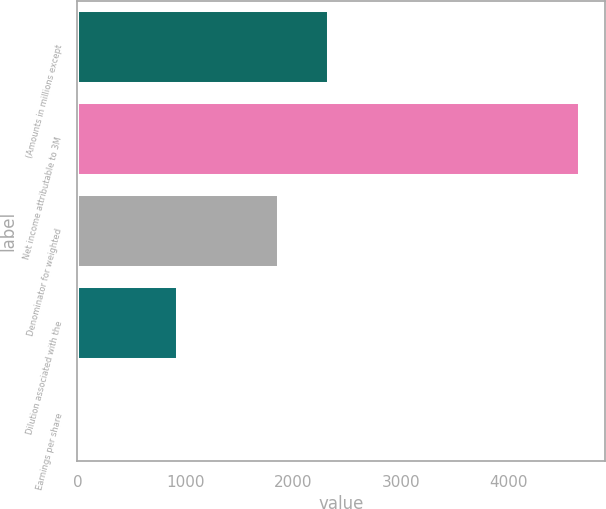Convert chart to OTSL. <chart><loc_0><loc_0><loc_500><loc_500><bar_chart><fcel>(Amounts in millions except<fcel>Net income attributable to 3M<fcel>Denominator for weighted<fcel>Dilution associated with the<fcel>Earnings per share<nl><fcel>2332.87<fcel>4659<fcel>1867.64<fcel>937.18<fcel>6.72<nl></chart> 